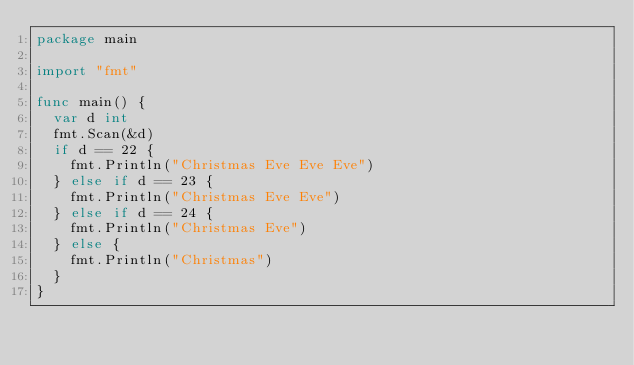Convert code to text. <code><loc_0><loc_0><loc_500><loc_500><_Go_>package main

import "fmt"

func main() {
	var d int
	fmt.Scan(&d)
	if d == 22 {
		fmt.Println("Christmas Eve Eve Eve")
	} else if d == 23 {
		fmt.Println("Christmas Eve Eve")
	} else if d == 24 {
		fmt.Println("Christmas Eve")
	} else {
		fmt.Println("Christmas")
	}
}
</code> 